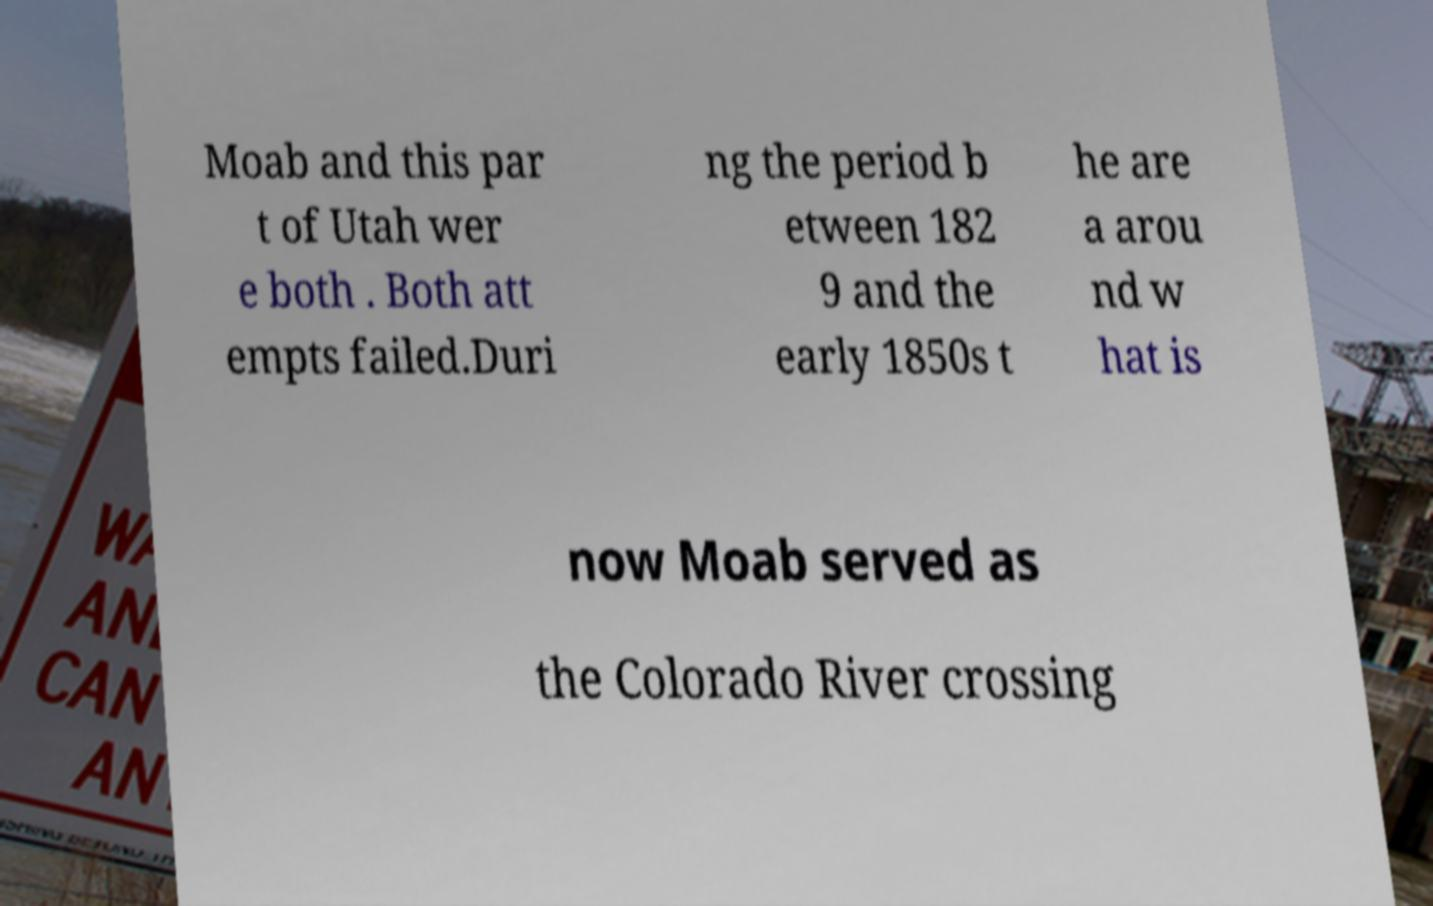Could you assist in decoding the text presented in this image and type it out clearly? Moab and this par t of Utah wer e both . Both att empts failed.Duri ng the period b etween 182 9 and the early 1850s t he are a arou nd w hat is now Moab served as the Colorado River crossing 